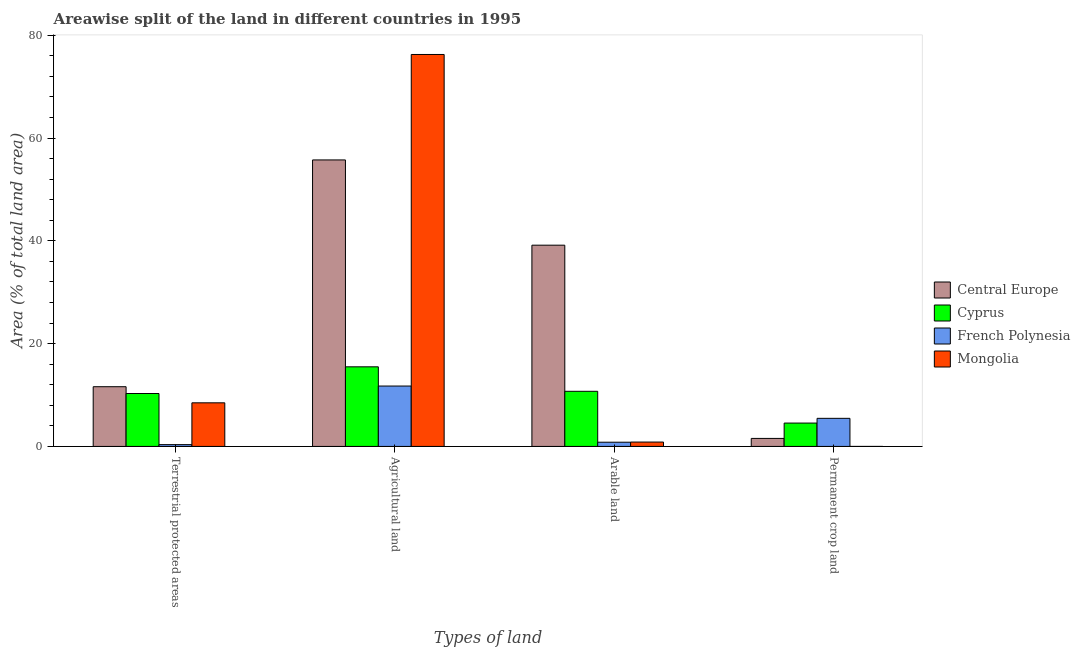Are the number of bars per tick equal to the number of legend labels?
Keep it short and to the point. Yes. Are the number of bars on each tick of the X-axis equal?
Make the answer very short. Yes. What is the label of the 2nd group of bars from the left?
Make the answer very short. Agricultural land. What is the percentage of land under terrestrial protection in Central Europe?
Ensure brevity in your answer.  11.62. Across all countries, what is the maximum percentage of land under terrestrial protection?
Keep it short and to the point. 11.62. Across all countries, what is the minimum percentage of land under terrestrial protection?
Give a very brief answer. 0.35. In which country was the percentage of area under arable land maximum?
Your answer should be compact. Central Europe. In which country was the percentage of area under permanent crop land minimum?
Offer a terse response. Mongolia. What is the total percentage of area under permanent crop land in the graph?
Provide a short and direct response. 11.57. What is the difference between the percentage of land under terrestrial protection in French Polynesia and that in Mongolia?
Offer a very short reply. -8.13. What is the difference between the percentage of area under permanent crop land in Mongolia and the percentage of area under arable land in Cyprus?
Your answer should be compact. -10.72. What is the average percentage of area under agricultural land per country?
Your answer should be compact. 39.81. What is the difference between the percentage of area under agricultural land and percentage of area under arable land in Central Europe?
Make the answer very short. 16.59. In how many countries, is the percentage of area under arable land greater than 4 %?
Give a very brief answer. 2. What is the ratio of the percentage of area under permanent crop land in Cyprus to that in Central Europe?
Make the answer very short. 2.91. What is the difference between the highest and the second highest percentage of area under arable land?
Offer a terse response. 28.43. What is the difference between the highest and the lowest percentage of land under terrestrial protection?
Ensure brevity in your answer.  11.27. Is the sum of the percentage of land under terrestrial protection in Cyprus and French Polynesia greater than the maximum percentage of area under permanent crop land across all countries?
Keep it short and to the point. Yes. Is it the case that in every country, the sum of the percentage of area under agricultural land and percentage of land under terrestrial protection is greater than the sum of percentage of area under arable land and percentage of area under permanent crop land?
Your answer should be compact. No. What does the 1st bar from the left in Permanent crop land represents?
Make the answer very short. Central Europe. What does the 4th bar from the right in Arable land represents?
Your response must be concise. Central Europe. Is it the case that in every country, the sum of the percentage of land under terrestrial protection and percentage of area under agricultural land is greater than the percentage of area under arable land?
Ensure brevity in your answer.  Yes. Are all the bars in the graph horizontal?
Offer a very short reply. No. How many countries are there in the graph?
Provide a short and direct response. 4. Does the graph contain any zero values?
Ensure brevity in your answer.  No. Does the graph contain grids?
Ensure brevity in your answer.  No. What is the title of the graph?
Provide a short and direct response. Areawise split of the land in different countries in 1995. Does "OECD members" appear as one of the legend labels in the graph?
Offer a very short reply. No. What is the label or title of the X-axis?
Your answer should be compact. Types of land. What is the label or title of the Y-axis?
Ensure brevity in your answer.  Area (% of total land area). What is the Area (% of total land area) of Central Europe in Terrestrial protected areas?
Give a very brief answer. 11.62. What is the Area (% of total land area) of Cyprus in Terrestrial protected areas?
Your response must be concise. 10.3. What is the Area (% of total land area) of French Polynesia in Terrestrial protected areas?
Offer a very short reply. 0.35. What is the Area (% of total land area) in Mongolia in Terrestrial protected areas?
Give a very brief answer. 8.48. What is the Area (% of total land area) in Central Europe in Agricultural land?
Your answer should be compact. 55.74. What is the Area (% of total land area) of Cyprus in Agricultural land?
Provide a succinct answer. 15.49. What is the Area (% of total land area) of French Polynesia in Agricultural land?
Give a very brief answer. 11.75. What is the Area (% of total land area) in Mongolia in Agricultural land?
Offer a terse response. 76.26. What is the Area (% of total land area) in Central Europe in Arable land?
Your answer should be compact. 39.15. What is the Area (% of total land area) of Cyprus in Arable land?
Keep it short and to the point. 10.73. What is the Area (% of total land area) of French Polynesia in Arable land?
Your response must be concise. 0.82. What is the Area (% of total land area) in Mongolia in Arable land?
Offer a terse response. 0.85. What is the Area (% of total land area) of Central Europe in Permanent crop land?
Your response must be concise. 1.56. What is the Area (% of total land area) in Cyprus in Permanent crop land?
Keep it short and to the point. 4.55. What is the Area (% of total land area) of French Polynesia in Permanent crop land?
Your answer should be compact. 5.46. What is the Area (% of total land area) of Mongolia in Permanent crop land?
Provide a succinct answer. 0. Across all Types of land, what is the maximum Area (% of total land area) of Central Europe?
Offer a terse response. 55.74. Across all Types of land, what is the maximum Area (% of total land area) in Cyprus?
Give a very brief answer. 15.49. Across all Types of land, what is the maximum Area (% of total land area) of French Polynesia?
Offer a very short reply. 11.75. Across all Types of land, what is the maximum Area (% of total land area) in Mongolia?
Your answer should be compact. 76.26. Across all Types of land, what is the minimum Area (% of total land area) of Central Europe?
Ensure brevity in your answer.  1.56. Across all Types of land, what is the minimum Area (% of total land area) of Cyprus?
Provide a succinct answer. 4.55. Across all Types of land, what is the minimum Area (% of total land area) of French Polynesia?
Give a very brief answer. 0.35. Across all Types of land, what is the minimum Area (% of total land area) in Mongolia?
Your answer should be very brief. 0. What is the total Area (% of total land area) in Central Europe in the graph?
Offer a very short reply. 108.07. What is the total Area (% of total land area) in Cyprus in the graph?
Keep it short and to the point. 41.05. What is the total Area (% of total land area) of French Polynesia in the graph?
Offer a very short reply. 18.38. What is the total Area (% of total land area) in Mongolia in the graph?
Your answer should be compact. 85.59. What is the difference between the Area (% of total land area) in Central Europe in Terrestrial protected areas and that in Agricultural land?
Your answer should be compact. -44.12. What is the difference between the Area (% of total land area) of Cyprus in Terrestrial protected areas and that in Agricultural land?
Your answer should be very brief. -5.19. What is the difference between the Area (% of total land area) of French Polynesia in Terrestrial protected areas and that in Agricultural land?
Keep it short and to the point. -11.4. What is the difference between the Area (% of total land area) of Mongolia in Terrestrial protected areas and that in Agricultural land?
Provide a short and direct response. -67.77. What is the difference between the Area (% of total land area) in Central Europe in Terrestrial protected areas and that in Arable land?
Make the answer very short. -27.54. What is the difference between the Area (% of total land area) in Cyprus in Terrestrial protected areas and that in Arable land?
Your answer should be very brief. -0.43. What is the difference between the Area (% of total land area) in French Polynesia in Terrestrial protected areas and that in Arable land?
Make the answer very short. -0.47. What is the difference between the Area (% of total land area) in Mongolia in Terrestrial protected areas and that in Arable land?
Your answer should be very brief. 7.63. What is the difference between the Area (% of total land area) in Central Europe in Terrestrial protected areas and that in Permanent crop land?
Offer a very short reply. 10.06. What is the difference between the Area (% of total land area) in Cyprus in Terrestrial protected areas and that in Permanent crop land?
Provide a succinct answer. 5.75. What is the difference between the Area (% of total land area) of French Polynesia in Terrestrial protected areas and that in Permanent crop land?
Provide a short and direct response. -5.11. What is the difference between the Area (% of total land area) in Mongolia in Terrestrial protected areas and that in Permanent crop land?
Offer a terse response. 8.48. What is the difference between the Area (% of total land area) in Central Europe in Agricultural land and that in Arable land?
Offer a very short reply. 16.59. What is the difference between the Area (% of total land area) in Cyprus in Agricultural land and that in Arable land?
Provide a succinct answer. 4.76. What is the difference between the Area (% of total land area) in French Polynesia in Agricultural land and that in Arable land?
Give a very brief answer. 10.93. What is the difference between the Area (% of total land area) in Mongolia in Agricultural land and that in Arable land?
Ensure brevity in your answer.  75.41. What is the difference between the Area (% of total land area) in Central Europe in Agricultural land and that in Permanent crop land?
Ensure brevity in your answer.  54.18. What is the difference between the Area (% of total land area) of Cyprus in Agricultural land and that in Permanent crop land?
Ensure brevity in your answer.  10.94. What is the difference between the Area (% of total land area) in French Polynesia in Agricultural land and that in Permanent crop land?
Provide a succinct answer. 6.28. What is the difference between the Area (% of total land area) of Mongolia in Agricultural land and that in Permanent crop land?
Offer a terse response. 76.26. What is the difference between the Area (% of total land area) of Central Europe in Arable land and that in Permanent crop land?
Offer a terse response. 37.6. What is the difference between the Area (% of total land area) of Cyprus in Arable land and that in Permanent crop land?
Your response must be concise. 6.18. What is the difference between the Area (% of total land area) of French Polynesia in Arable land and that in Permanent crop land?
Ensure brevity in your answer.  -4.64. What is the difference between the Area (% of total land area) in Mongolia in Arable land and that in Permanent crop land?
Offer a very short reply. 0.85. What is the difference between the Area (% of total land area) in Central Europe in Terrestrial protected areas and the Area (% of total land area) in Cyprus in Agricultural land?
Keep it short and to the point. -3.87. What is the difference between the Area (% of total land area) of Central Europe in Terrestrial protected areas and the Area (% of total land area) of French Polynesia in Agricultural land?
Your answer should be compact. -0.13. What is the difference between the Area (% of total land area) in Central Europe in Terrestrial protected areas and the Area (% of total land area) in Mongolia in Agricultural land?
Provide a succinct answer. -64.64. What is the difference between the Area (% of total land area) in Cyprus in Terrestrial protected areas and the Area (% of total land area) in French Polynesia in Agricultural land?
Ensure brevity in your answer.  -1.45. What is the difference between the Area (% of total land area) of Cyprus in Terrestrial protected areas and the Area (% of total land area) of Mongolia in Agricultural land?
Your answer should be very brief. -65.96. What is the difference between the Area (% of total land area) in French Polynesia in Terrestrial protected areas and the Area (% of total land area) in Mongolia in Agricultural land?
Keep it short and to the point. -75.91. What is the difference between the Area (% of total land area) in Central Europe in Terrestrial protected areas and the Area (% of total land area) in Cyprus in Arable land?
Offer a terse response. 0.89. What is the difference between the Area (% of total land area) of Central Europe in Terrestrial protected areas and the Area (% of total land area) of French Polynesia in Arable land?
Your answer should be compact. 10.8. What is the difference between the Area (% of total land area) of Central Europe in Terrestrial protected areas and the Area (% of total land area) of Mongolia in Arable land?
Offer a very short reply. 10.77. What is the difference between the Area (% of total land area) of Cyprus in Terrestrial protected areas and the Area (% of total land area) of French Polynesia in Arable land?
Offer a very short reply. 9.48. What is the difference between the Area (% of total land area) of Cyprus in Terrestrial protected areas and the Area (% of total land area) of Mongolia in Arable land?
Offer a very short reply. 9.45. What is the difference between the Area (% of total land area) in French Polynesia in Terrestrial protected areas and the Area (% of total land area) in Mongolia in Arable land?
Offer a terse response. -0.5. What is the difference between the Area (% of total land area) of Central Europe in Terrestrial protected areas and the Area (% of total land area) of Cyprus in Permanent crop land?
Provide a short and direct response. 7.07. What is the difference between the Area (% of total land area) in Central Europe in Terrestrial protected areas and the Area (% of total land area) in French Polynesia in Permanent crop land?
Keep it short and to the point. 6.15. What is the difference between the Area (% of total land area) of Central Europe in Terrestrial protected areas and the Area (% of total land area) of Mongolia in Permanent crop land?
Your answer should be very brief. 11.62. What is the difference between the Area (% of total land area) of Cyprus in Terrestrial protected areas and the Area (% of total land area) of French Polynesia in Permanent crop land?
Offer a very short reply. 4.83. What is the difference between the Area (% of total land area) in Cyprus in Terrestrial protected areas and the Area (% of total land area) in Mongolia in Permanent crop land?
Offer a very short reply. 10.3. What is the difference between the Area (% of total land area) in French Polynesia in Terrestrial protected areas and the Area (% of total land area) in Mongolia in Permanent crop land?
Offer a terse response. 0.35. What is the difference between the Area (% of total land area) of Central Europe in Agricultural land and the Area (% of total land area) of Cyprus in Arable land?
Ensure brevity in your answer.  45.02. What is the difference between the Area (% of total land area) of Central Europe in Agricultural land and the Area (% of total land area) of French Polynesia in Arable land?
Your answer should be compact. 54.92. What is the difference between the Area (% of total land area) of Central Europe in Agricultural land and the Area (% of total land area) of Mongolia in Arable land?
Keep it short and to the point. 54.89. What is the difference between the Area (% of total land area) in Cyprus in Agricultural land and the Area (% of total land area) in French Polynesia in Arable land?
Provide a succinct answer. 14.67. What is the difference between the Area (% of total land area) in Cyprus in Agricultural land and the Area (% of total land area) in Mongolia in Arable land?
Provide a succinct answer. 14.64. What is the difference between the Area (% of total land area) in French Polynesia in Agricultural land and the Area (% of total land area) in Mongolia in Arable land?
Offer a terse response. 10.9. What is the difference between the Area (% of total land area) of Central Europe in Agricultural land and the Area (% of total land area) of Cyprus in Permanent crop land?
Your answer should be very brief. 51.2. What is the difference between the Area (% of total land area) in Central Europe in Agricultural land and the Area (% of total land area) in French Polynesia in Permanent crop land?
Your answer should be compact. 50.28. What is the difference between the Area (% of total land area) of Central Europe in Agricultural land and the Area (% of total land area) of Mongolia in Permanent crop land?
Your answer should be very brief. 55.74. What is the difference between the Area (% of total land area) in Cyprus in Agricultural land and the Area (% of total land area) in French Polynesia in Permanent crop land?
Your answer should be compact. 10.02. What is the difference between the Area (% of total land area) of Cyprus in Agricultural land and the Area (% of total land area) of Mongolia in Permanent crop land?
Offer a very short reply. 15.49. What is the difference between the Area (% of total land area) in French Polynesia in Agricultural land and the Area (% of total land area) in Mongolia in Permanent crop land?
Provide a succinct answer. 11.75. What is the difference between the Area (% of total land area) in Central Europe in Arable land and the Area (% of total land area) in Cyprus in Permanent crop land?
Give a very brief answer. 34.61. What is the difference between the Area (% of total land area) in Central Europe in Arable land and the Area (% of total land area) in French Polynesia in Permanent crop land?
Make the answer very short. 33.69. What is the difference between the Area (% of total land area) of Central Europe in Arable land and the Area (% of total land area) of Mongolia in Permanent crop land?
Provide a short and direct response. 39.15. What is the difference between the Area (% of total land area) in Cyprus in Arable land and the Area (% of total land area) in French Polynesia in Permanent crop land?
Give a very brief answer. 5.26. What is the difference between the Area (% of total land area) in Cyprus in Arable land and the Area (% of total land area) in Mongolia in Permanent crop land?
Offer a very short reply. 10.72. What is the difference between the Area (% of total land area) in French Polynesia in Arable land and the Area (% of total land area) in Mongolia in Permanent crop land?
Make the answer very short. 0.82. What is the average Area (% of total land area) of Central Europe per Types of land?
Your answer should be compact. 27.02. What is the average Area (% of total land area) of Cyprus per Types of land?
Offer a terse response. 10.26. What is the average Area (% of total land area) in French Polynesia per Types of land?
Your response must be concise. 4.6. What is the average Area (% of total land area) of Mongolia per Types of land?
Provide a short and direct response. 21.4. What is the difference between the Area (% of total land area) in Central Europe and Area (% of total land area) in Cyprus in Terrestrial protected areas?
Give a very brief answer. 1.32. What is the difference between the Area (% of total land area) in Central Europe and Area (% of total land area) in French Polynesia in Terrestrial protected areas?
Keep it short and to the point. 11.27. What is the difference between the Area (% of total land area) in Central Europe and Area (% of total land area) in Mongolia in Terrestrial protected areas?
Offer a very short reply. 3.14. What is the difference between the Area (% of total land area) of Cyprus and Area (% of total land area) of French Polynesia in Terrestrial protected areas?
Your answer should be very brief. 9.95. What is the difference between the Area (% of total land area) of Cyprus and Area (% of total land area) of Mongolia in Terrestrial protected areas?
Your answer should be very brief. 1.81. What is the difference between the Area (% of total land area) in French Polynesia and Area (% of total land area) in Mongolia in Terrestrial protected areas?
Keep it short and to the point. -8.13. What is the difference between the Area (% of total land area) of Central Europe and Area (% of total land area) of Cyprus in Agricultural land?
Provide a short and direct response. 40.25. What is the difference between the Area (% of total land area) of Central Europe and Area (% of total land area) of French Polynesia in Agricultural land?
Ensure brevity in your answer.  43.99. What is the difference between the Area (% of total land area) of Central Europe and Area (% of total land area) of Mongolia in Agricultural land?
Keep it short and to the point. -20.52. What is the difference between the Area (% of total land area) in Cyprus and Area (% of total land area) in French Polynesia in Agricultural land?
Offer a terse response. 3.74. What is the difference between the Area (% of total land area) of Cyprus and Area (% of total land area) of Mongolia in Agricultural land?
Ensure brevity in your answer.  -60.77. What is the difference between the Area (% of total land area) of French Polynesia and Area (% of total land area) of Mongolia in Agricultural land?
Your response must be concise. -64.51. What is the difference between the Area (% of total land area) of Central Europe and Area (% of total land area) of Cyprus in Arable land?
Offer a terse response. 28.43. What is the difference between the Area (% of total land area) in Central Europe and Area (% of total land area) in French Polynesia in Arable land?
Your response must be concise. 38.33. What is the difference between the Area (% of total land area) of Central Europe and Area (% of total land area) of Mongolia in Arable land?
Your answer should be very brief. 38.3. What is the difference between the Area (% of total land area) of Cyprus and Area (% of total land area) of French Polynesia in Arable land?
Your answer should be very brief. 9.91. What is the difference between the Area (% of total land area) in Cyprus and Area (% of total land area) in Mongolia in Arable land?
Your response must be concise. 9.87. What is the difference between the Area (% of total land area) in French Polynesia and Area (% of total land area) in Mongolia in Arable land?
Your answer should be compact. -0.03. What is the difference between the Area (% of total land area) in Central Europe and Area (% of total land area) in Cyprus in Permanent crop land?
Your answer should be compact. -2.99. What is the difference between the Area (% of total land area) of Central Europe and Area (% of total land area) of French Polynesia in Permanent crop land?
Keep it short and to the point. -3.91. What is the difference between the Area (% of total land area) of Central Europe and Area (% of total land area) of Mongolia in Permanent crop land?
Offer a terse response. 1.56. What is the difference between the Area (% of total land area) of Cyprus and Area (% of total land area) of French Polynesia in Permanent crop land?
Offer a very short reply. -0.92. What is the difference between the Area (% of total land area) in Cyprus and Area (% of total land area) in Mongolia in Permanent crop land?
Give a very brief answer. 4.54. What is the difference between the Area (% of total land area) of French Polynesia and Area (% of total land area) of Mongolia in Permanent crop land?
Give a very brief answer. 5.46. What is the ratio of the Area (% of total land area) of Central Europe in Terrestrial protected areas to that in Agricultural land?
Make the answer very short. 0.21. What is the ratio of the Area (% of total land area) in Cyprus in Terrestrial protected areas to that in Agricultural land?
Make the answer very short. 0.66. What is the ratio of the Area (% of total land area) in French Polynesia in Terrestrial protected areas to that in Agricultural land?
Offer a very short reply. 0.03. What is the ratio of the Area (% of total land area) of Mongolia in Terrestrial protected areas to that in Agricultural land?
Your answer should be compact. 0.11. What is the ratio of the Area (% of total land area) of Central Europe in Terrestrial protected areas to that in Arable land?
Provide a short and direct response. 0.3. What is the ratio of the Area (% of total land area) in Cyprus in Terrestrial protected areas to that in Arable land?
Offer a terse response. 0.96. What is the ratio of the Area (% of total land area) of French Polynesia in Terrestrial protected areas to that in Arable land?
Offer a very short reply. 0.43. What is the ratio of the Area (% of total land area) of Mongolia in Terrestrial protected areas to that in Arable land?
Give a very brief answer. 9.98. What is the ratio of the Area (% of total land area) of Central Europe in Terrestrial protected areas to that in Permanent crop land?
Your answer should be compact. 7.45. What is the ratio of the Area (% of total land area) of Cyprus in Terrestrial protected areas to that in Permanent crop land?
Give a very brief answer. 2.27. What is the ratio of the Area (% of total land area) of French Polynesia in Terrestrial protected areas to that in Permanent crop land?
Offer a terse response. 0.06. What is the ratio of the Area (% of total land area) in Mongolia in Terrestrial protected areas to that in Permanent crop land?
Your response must be concise. 1.32e+04. What is the ratio of the Area (% of total land area) in Central Europe in Agricultural land to that in Arable land?
Give a very brief answer. 1.42. What is the ratio of the Area (% of total land area) in Cyprus in Agricultural land to that in Arable land?
Your response must be concise. 1.44. What is the ratio of the Area (% of total land area) in French Polynesia in Agricultural land to that in Arable land?
Keep it short and to the point. 14.33. What is the ratio of the Area (% of total land area) in Mongolia in Agricultural land to that in Arable land?
Your answer should be very brief. 89.68. What is the ratio of the Area (% of total land area) of Central Europe in Agricultural land to that in Permanent crop land?
Offer a very short reply. 35.75. What is the ratio of the Area (% of total land area) of Cyprus in Agricultural land to that in Permanent crop land?
Ensure brevity in your answer.  3.41. What is the ratio of the Area (% of total land area) in French Polynesia in Agricultural land to that in Permanent crop land?
Make the answer very short. 2.15. What is the ratio of the Area (% of total land area) of Mongolia in Agricultural land to that in Permanent crop land?
Give a very brief answer. 1.18e+05. What is the ratio of the Area (% of total land area) in Central Europe in Arable land to that in Permanent crop land?
Offer a terse response. 25.11. What is the ratio of the Area (% of total land area) in Cyprus in Arable land to that in Permanent crop land?
Make the answer very short. 2.36. What is the ratio of the Area (% of total land area) in French Polynesia in Arable land to that in Permanent crop land?
Offer a terse response. 0.15. What is the ratio of the Area (% of total land area) in Mongolia in Arable land to that in Permanent crop land?
Your answer should be very brief. 1321. What is the difference between the highest and the second highest Area (% of total land area) in Central Europe?
Ensure brevity in your answer.  16.59. What is the difference between the highest and the second highest Area (% of total land area) in Cyprus?
Your answer should be very brief. 4.76. What is the difference between the highest and the second highest Area (% of total land area) of French Polynesia?
Ensure brevity in your answer.  6.28. What is the difference between the highest and the second highest Area (% of total land area) in Mongolia?
Your answer should be compact. 67.77. What is the difference between the highest and the lowest Area (% of total land area) in Central Europe?
Offer a terse response. 54.18. What is the difference between the highest and the lowest Area (% of total land area) of Cyprus?
Your answer should be very brief. 10.94. What is the difference between the highest and the lowest Area (% of total land area) of French Polynesia?
Give a very brief answer. 11.4. What is the difference between the highest and the lowest Area (% of total land area) in Mongolia?
Provide a succinct answer. 76.26. 